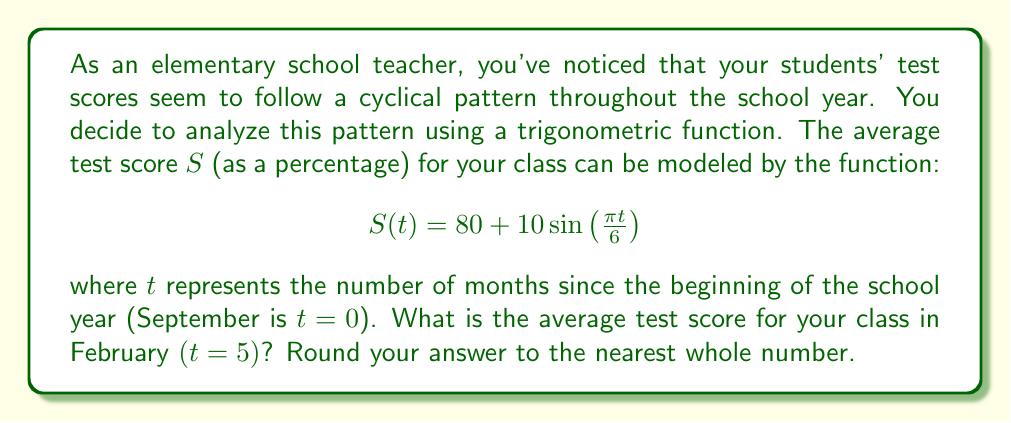Help me with this question. To solve this problem, we need to follow these steps:

1. Understand the given function:
   $$S(t) = 80 + 10\sin\left(\frac{\pi t}{6}\right)$$
   - 80 is the average score around which the function oscillates
   - 10 is the amplitude of the oscillation
   - $\frac{\pi}{6}$ is the frequency, which makes the function complete one cycle every 12 months

2. Identify the value of $t$ for February:
   - September is $t=0$
   - February is 5 months after September, so $t=5$

3. Substitute $t=5$ into the function:
   $$S(5) = 80 + 10\sin\left(\frac{\pi \cdot 5}{6}\right)$$

4. Calculate the value inside the sine function:
   $$\frac{\pi \cdot 5}{6} \approx 2.618$$

5. Calculate $\sin(2.618)$:
   $$\sin(2.618) \approx 0.8660$$

6. Multiply this by 10 and add to 80:
   $$80 + 10 \cdot 0.8660 = 80 + 8.660 = 88.660$$

7. Round to the nearest whole number:
   88.660 rounds to 89

This analysis shows how trigonometric functions can model cyclical patterns in student performance, which could be influenced by various factors such as seasonal changes, holiday breaks, or curriculum pacing.
Answer: 89 